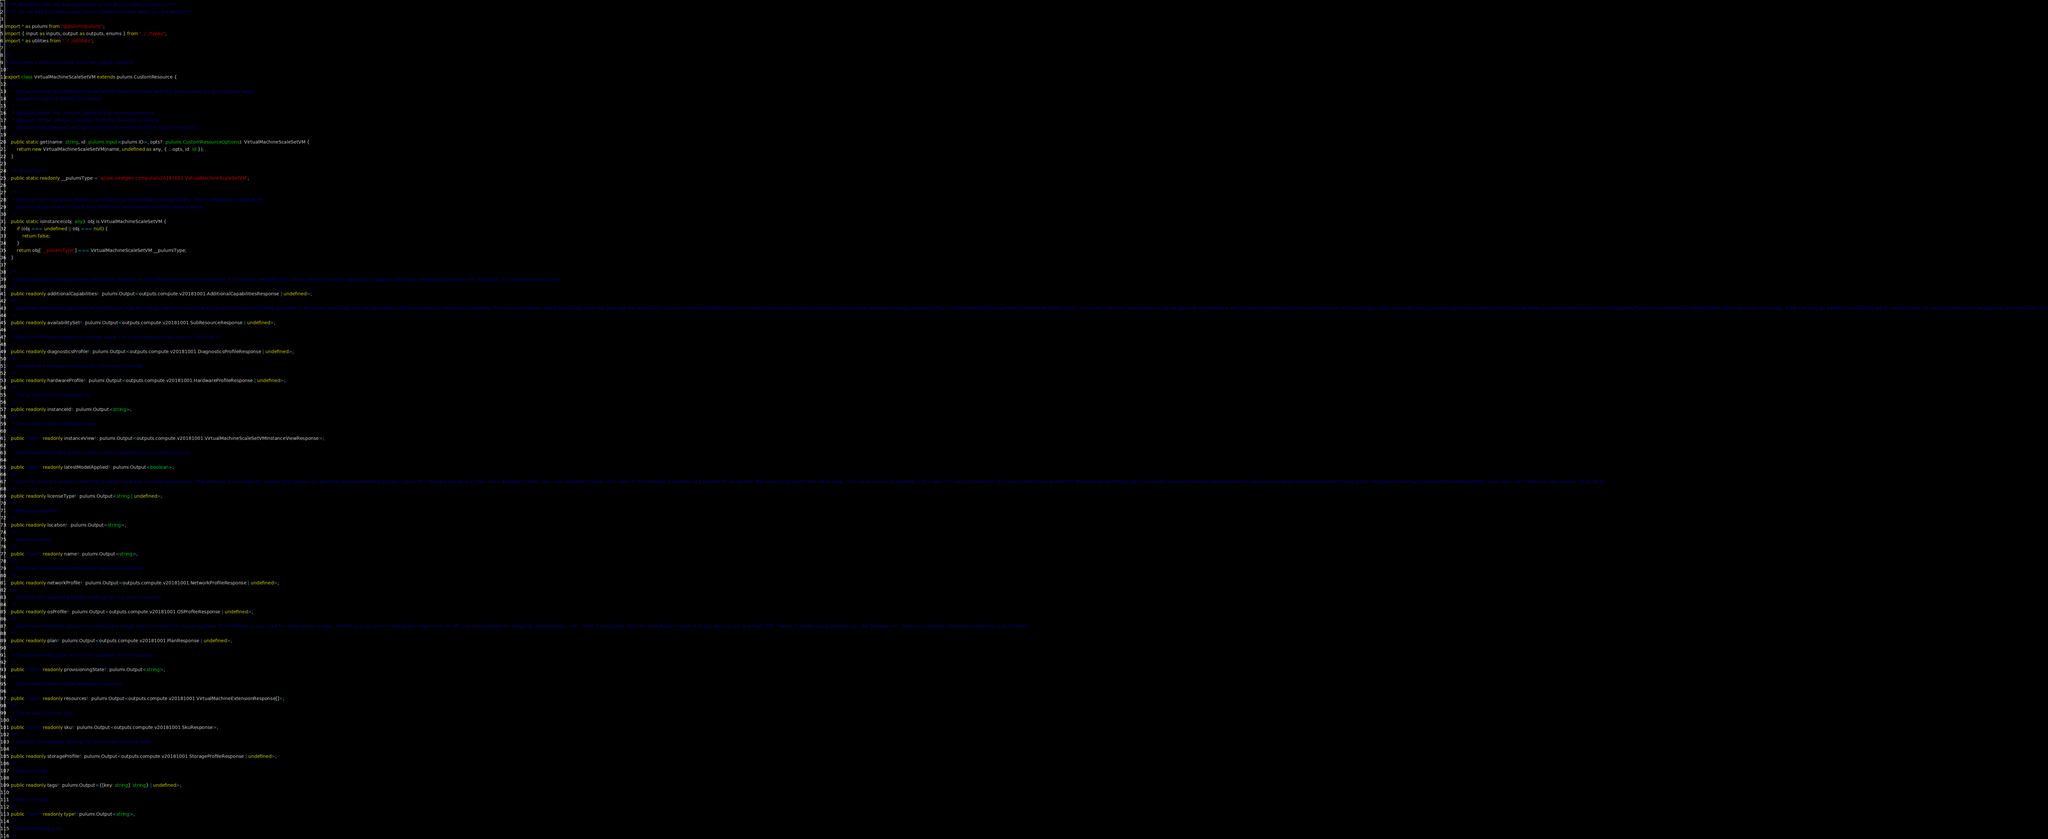<code> <loc_0><loc_0><loc_500><loc_500><_TypeScript_>// *** WARNING: this file was generated by the Pulumi SDK Generator. ***
// *** Do not edit by hand unless you're certain you know what you are doing! ***

import * as pulumi from "@pulumi/pulumi";
import { input as inputs, output as outputs, enums } from "../../types";
import * as utilities from "../../utilities";

/**
 * Describes a virtual machine scale set virtual machine.
 */
export class VirtualMachineScaleSetVM extends pulumi.CustomResource {
    /**
     * Get an existing VirtualMachineScaleSetVM resource's state with the given name, ID, and optional extra
     * properties used to qualify the lookup.
     *
     * @param name The _unique_ name of the resulting resource.
     * @param id The _unique_ provider ID of the resource to lookup.
     * @param opts Optional settings to control the behavior of the CustomResource.
     */
    public static get(name: string, id: pulumi.Input<pulumi.ID>, opts?: pulumi.CustomResourceOptions): VirtualMachineScaleSetVM {
        return new VirtualMachineScaleSetVM(name, undefined as any, { ...opts, id: id });
    }

    /** @internal */
    public static readonly __pulumiType = 'azure-nextgen:compute/v20181001:VirtualMachineScaleSetVM';

    /**
     * Returns true if the given object is an instance of VirtualMachineScaleSetVM.  This is designed to work even
     * when multiple copies of the Pulumi SDK have been loaded into the same process.
     */
    public static isInstance(obj: any): obj is VirtualMachineScaleSetVM {
        if (obj === undefined || obj === null) {
            return false;
        }
        return obj['__pulumiType'] === VirtualMachineScaleSetVM.__pulumiType;
    }

    /**
     * Specifies additional capabilities enabled or disabled on the virtual machine in the scale set. For instance: whether the virtual machine has the capability to support attaching managed data disks with UltraSSD_LRS storage account type.
     */
    public readonly additionalCapabilities!: pulumi.Output<outputs.compute.v20181001.AdditionalCapabilitiesResponse | undefined>;
    /**
     * Specifies information about the availability set that the virtual machine should be assigned to. Virtual machines specified in the same availability set are allocated to different nodes to maximize availability. For more information about availability sets, see [Manage the availability of virtual machines](https://docs.microsoft.com/azure/virtual-machines/virtual-machines-windows-manage-availability?toc=%2fazure%2fvirtual-machines%2fwindows%2ftoc.json). <br><br> For more information on Azure planned maintenance, see [Planned maintenance for virtual machines in Azure](https://docs.microsoft.com/azure/virtual-machines/virtual-machines-windows-planned-maintenance?toc=%2fazure%2fvirtual-machines%2fwindows%2ftoc.json) <br><br> Currently, a VM can only be added to availability set at creation time. An existing VM cannot be added to an availability set.
     */
    public readonly availabilitySet!: pulumi.Output<outputs.compute.v20181001.SubResourceResponse | undefined>;
    /**
     * Specifies the boot diagnostic settings state. <br><br>Minimum api-version: 2015-06-15.
     */
    public readonly diagnosticsProfile!: pulumi.Output<outputs.compute.v20181001.DiagnosticsProfileResponse | undefined>;
    /**
     * Specifies the hardware settings for the virtual machine.
     */
    public readonly hardwareProfile!: pulumi.Output<outputs.compute.v20181001.HardwareProfileResponse | undefined>;
    /**
     * The virtual machine instance ID.
     */
    public readonly instanceId!: pulumi.Output<string>;
    /**
     * The virtual machine instance view.
     */
    public /*out*/ readonly instanceView!: pulumi.Output<outputs.compute.v20181001.VirtualMachineScaleSetVMInstanceViewResponse>;
    /**
     * Specifies whether the latest model has been applied to the virtual machine.
     */
    public /*out*/ readonly latestModelApplied!: pulumi.Output<boolean>;
    /**
     * Specifies that the image or disk that is being used was licensed on-premises. This element is only used for images that contain the Windows Server operating system. <br><br> Possible values are: <br><br> Windows_Client <br><br> Windows_Server <br><br> If this element is included in a request for an update, the value must match the initial value. This value cannot be updated. <br><br> For more information, see [Azure Hybrid Use Benefit for Windows Server](https://docs.microsoft.com/azure/virtual-machines/virtual-machines-windows-hybrid-use-benefit-licensing?toc=%2fazure%2fvirtual-machines%2fwindows%2ftoc.json) <br><br> Minimum api-version: 2015-06-15
     */
    public readonly licenseType!: pulumi.Output<string | undefined>;
    /**
     * Resource location
     */
    public readonly location!: pulumi.Output<string>;
    /**
     * Resource name
     */
    public /*out*/ readonly name!: pulumi.Output<string>;
    /**
     * Specifies the network interfaces of the virtual machine.
     */
    public readonly networkProfile!: pulumi.Output<outputs.compute.v20181001.NetworkProfileResponse | undefined>;
    /**
     * Specifies the operating system settings for the virtual machine.
     */
    public readonly osProfile!: pulumi.Output<outputs.compute.v20181001.OSProfileResponse | undefined>;
    /**
     * Specifies information about the marketplace image used to create the virtual machine. This element is only used for marketplace images. Before you can use a marketplace image from an API, you must enable the image for programmatic use.  In the Azure portal, find the marketplace image that you want to use and then click **Want to deploy programmatically, Get Started ->**. Enter any required information and then click **Save**.
     */
    public readonly plan!: pulumi.Output<outputs.compute.v20181001.PlanResponse | undefined>;
    /**
     * The provisioning state, which only appears in the response.
     */
    public /*out*/ readonly provisioningState!: pulumi.Output<string>;
    /**
     * The virtual machine child extension resources.
     */
    public /*out*/ readonly resources!: pulumi.Output<outputs.compute.v20181001.VirtualMachineExtensionResponse[]>;
    /**
     * The virtual machine SKU.
     */
    public /*out*/ readonly sku!: pulumi.Output<outputs.compute.v20181001.SkuResponse>;
    /**
     * Specifies the storage settings for the virtual machine disks.
     */
    public readonly storageProfile!: pulumi.Output<outputs.compute.v20181001.StorageProfileResponse | undefined>;
    /**
     * Resource tags
     */
    public readonly tags!: pulumi.Output<{[key: string]: string} | undefined>;
    /**
     * Resource type
     */
    public /*out*/ readonly type!: pulumi.Output<string>;
    /**
     * Azure VM unique ID.
     */</code> 